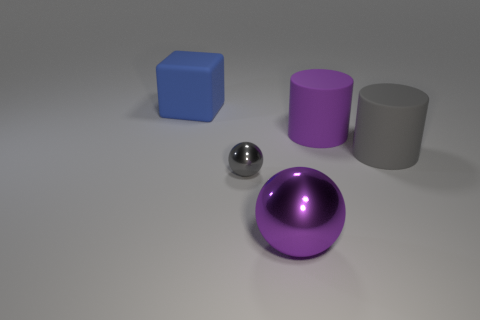Add 2 big cubes. How many objects exist? 7 Subtract 1 cubes. How many cubes are left? 0 Add 4 big purple matte objects. How many big purple matte objects are left? 5 Add 1 tiny red cylinders. How many tiny red cylinders exist? 1 Subtract 0 cyan cylinders. How many objects are left? 5 Subtract all balls. How many objects are left? 3 Subtract all blue cylinders. Subtract all brown blocks. How many cylinders are left? 2 Subtract all blue cubes. How many gray cylinders are left? 1 Subtract all gray metallic spheres. Subtract all big shiny spheres. How many objects are left? 3 